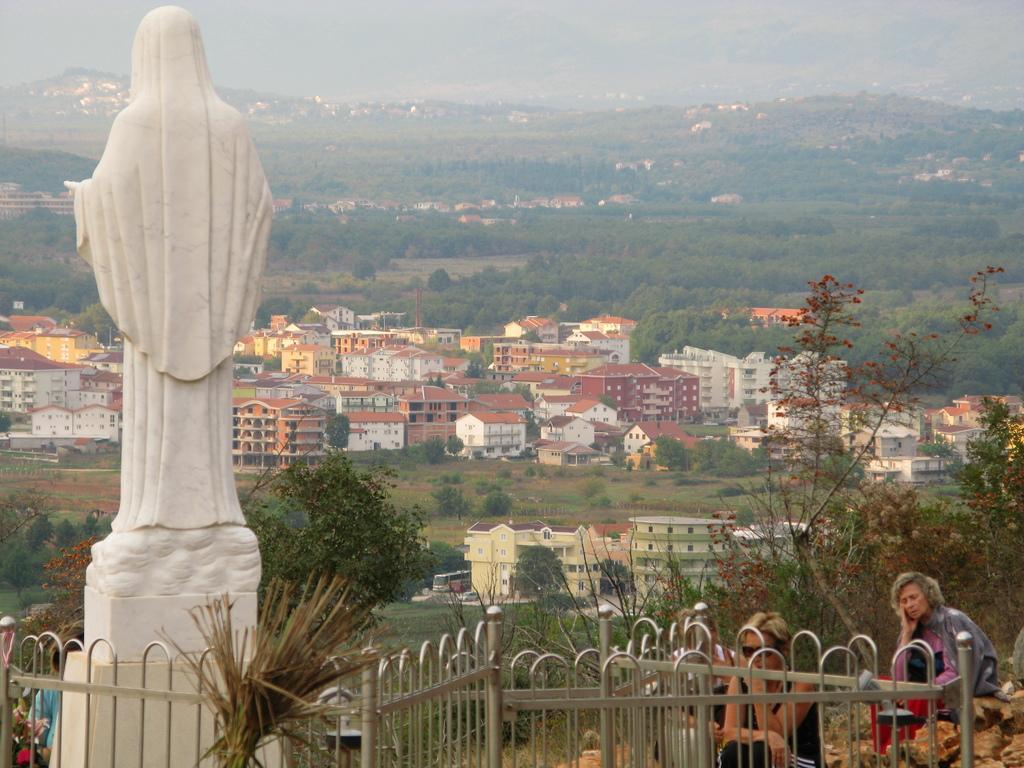Describe this image in one or two sentences. In this image I can see a white colour sculpture and I can see few people. In the background I can see number of trees and number of buildings. 